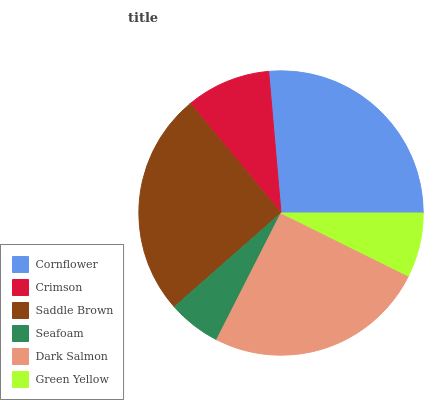Is Seafoam the minimum?
Answer yes or no. Yes. Is Cornflower the maximum?
Answer yes or no. Yes. Is Crimson the minimum?
Answer yes or no. No. Is Crimson the maximum?
Answer yes or no. No. Is Cornflower greater than Crimson?
Answer yes or no. Yes. Is Crimson less than Cornflower?
Answer yes or no. Yes. Is Crimson greater than Cornflower?
Answer yes or no. No. Is Cornflower less than Crimson?
Answer yes or no. No. Is Dark Salmon the high median?
Answer yes or no. Yes. Is Crimson the low median?
Answer yes or no. Yes. Is Cornflower the high median?
Answer yes or no. No. Is Green Yellow the low median?
Answer yes or no. No. 